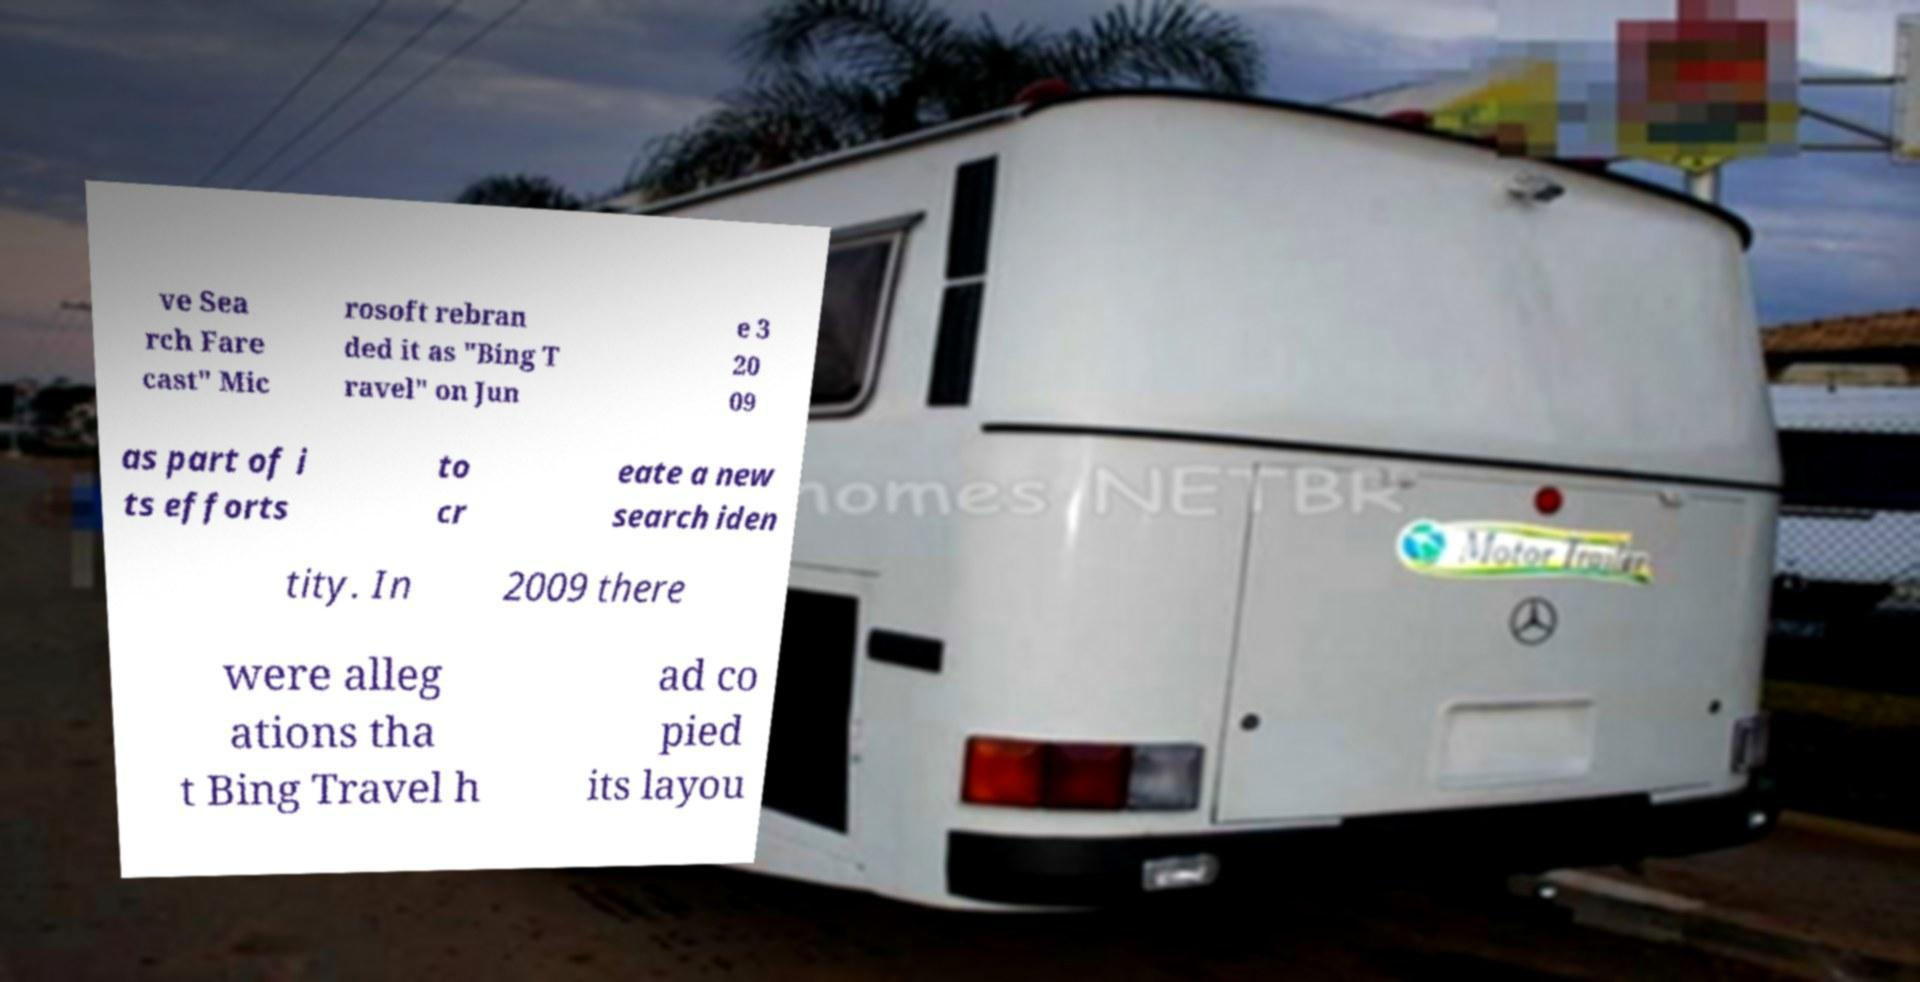Please identify and transcribe the text found in this image. ve Sea rch Fare cast" Mic rosoft rebran ded it as "Bing T ravel" on Jun e 3 20 09 as part of i ts efforts to cr eate a new search iden tity. In 2009 there were alleg ations tha t Bing Travel h ad co pied its layou 